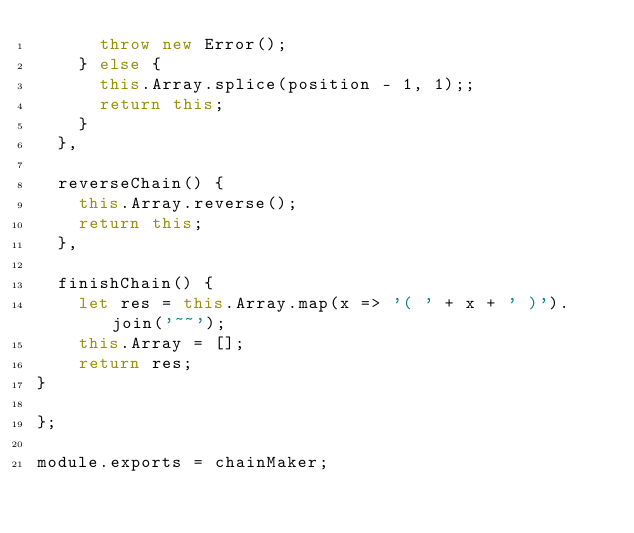<code> <loc_0><loc_0><loc_500><loc_500><_JavaScript_>      throw new Error();
    } else {
      this.Array.splice(position - 1, 1);;
      return this;
    }
  },

  reverseChain() {
    this.Array.reverse();
    return this;
  },
  
  finishChain() {
    let res = this.Array.map(x => '( ' + x + ' )').join('~~');
    this.Array = [];
    return res;
}

};

module.exports = chainMaker;
</code> 